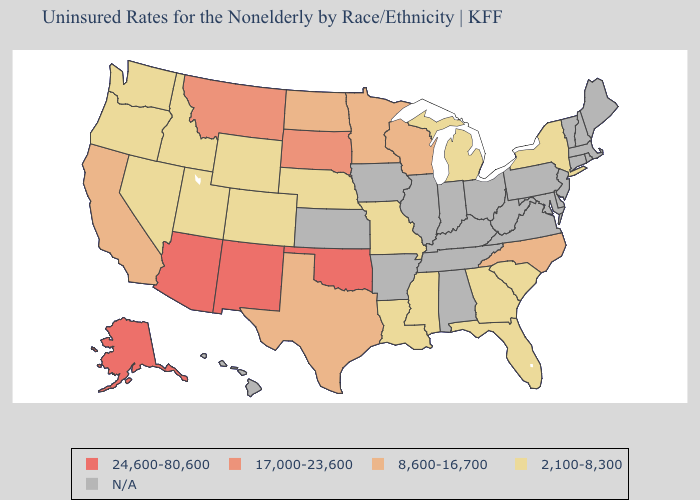Which states hav the highest value in the Northeast?
Short answer required. New York. Which states have the lowest value in the West?
Concise answer only. Colorado, Idaho, Nevada, Oregon, Utah, Washington, Wyoming. What is the lowest value in the South?
Quick response, please. 2,100-8,300. What is the value of Indiana?
Quick response, please. N/A. Name the states that have a value in the range 2,100-8,300?
Keep it brief. Colorado, Florida, Georgia, Idaho, Louisiana, Michigan, Mississippi, Missouri, Nebraska, Nevada, New York, Oregon, South Carolina, Utah, Washington, Wyoming. What is the value of West Virginia?
Write a very short answer. N/A. Among the states that border Montana , which have the highest value?
Short answer required. South Dakota. Name the states that have a value in the range 2,100-8,300?
Be succinct. Colorado, Florida, Georgia, Idaho, Louisiana, Michigan, Mississippi, Missouri, Nebraska, Nevada, New York, Oregon, South Carolina, Utah, Washington, Wyoming. What is the value of Ohio?
Quick response, please. N/A. What is the value of North Carolina?
Quick response, please. 8,600-16,700. Does the map have missing data?
Give a very brief answer. Yes. What is the value of Vermont?
Answer briefly. N/A. Does the first symbol in the legend represent the smallest category?
Short answer required. No. 